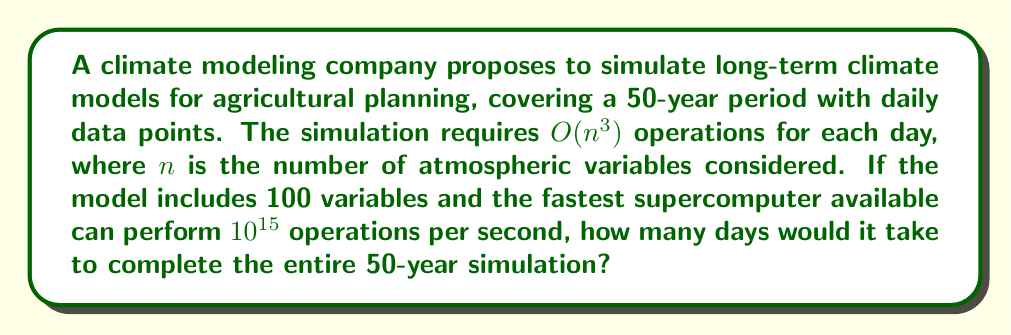Provide a solution to this math problem. Let's approach this problem step by step:

1. Calculate the number of days in 50 years:
   $50 \text{ years} \times 365 \text{ days/year} = 18,250 \text{ days}$

2. Calculate the number of operations required for one day:
   $O(n^3) = O(100^3) = 1,000,000 \text{ operations}$

3. Calculate the total number of operations for the entire simulation:
   $18,250 \text{ days} \times 1,000,000 \text{ operations/day} = 1.825 \times 10^{10} \text{ operations}$

4. Calculate the number of operations the supercomputer can perform in one day:
   $10^{15} \text{ operations/second} \times 86,400 \text{ seconds/day} = 8.64 \times 10^{19} \text{ operations/day}$

5. Calculate the number of days required to complete the simulation:
   $\text{Days required} = \frac{\text{Total operations}}{\text{Operations per day}}$
   
   $\text{Days required} = \frac{1.825 \times 10^{10}}{8.64 \times 10^{19}} = 2.113 \times 10^{-10} \text{ days}$

6. Convert the result to seconds for a more meaningful representation:
   $2.113 \times 10^{-10} \text{ days} \times 86,400 \text{ seconds/day} = 1.826 \times 10^{-5} \text{ seconds}$
Answer: The entire 50-year simulation would take approximately $1.826 \times 10^{-5}$ seconds, or about 18.26 microseconds, to complete on the given supercomputer. 